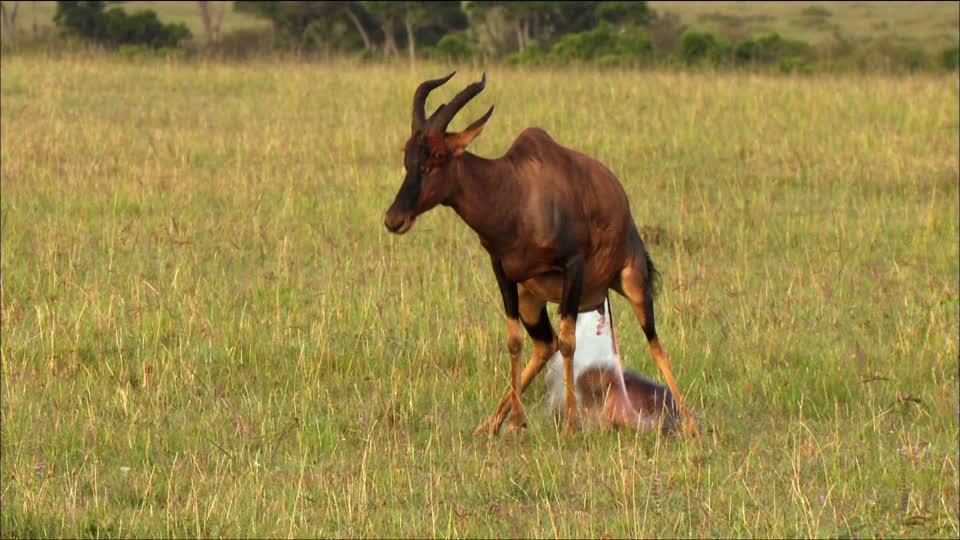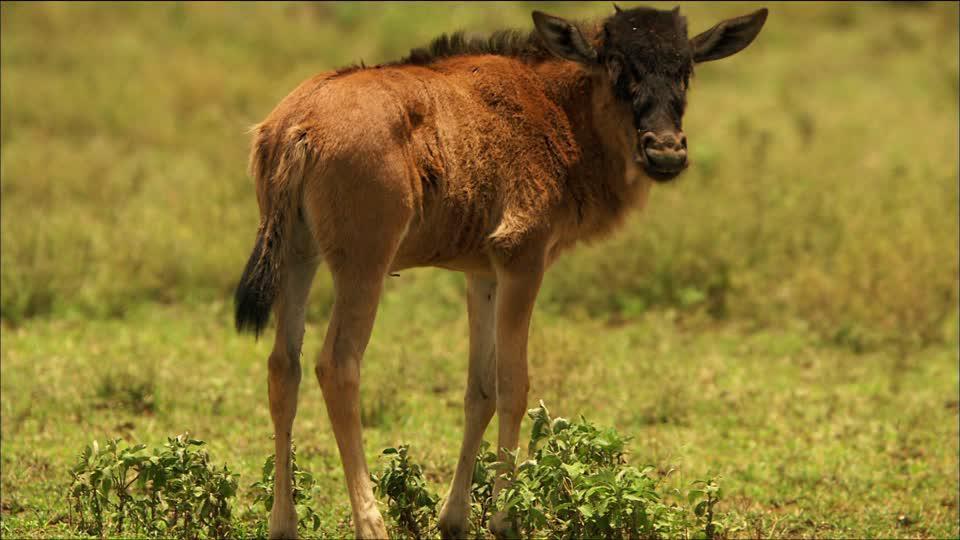The first image is the image on the left, the second image is the image on the right. Considering the images on both sides, is "The animal in the image on the left is facing right, and the animal in the image on the right is facing left." valid? Answer yes or no. No. 